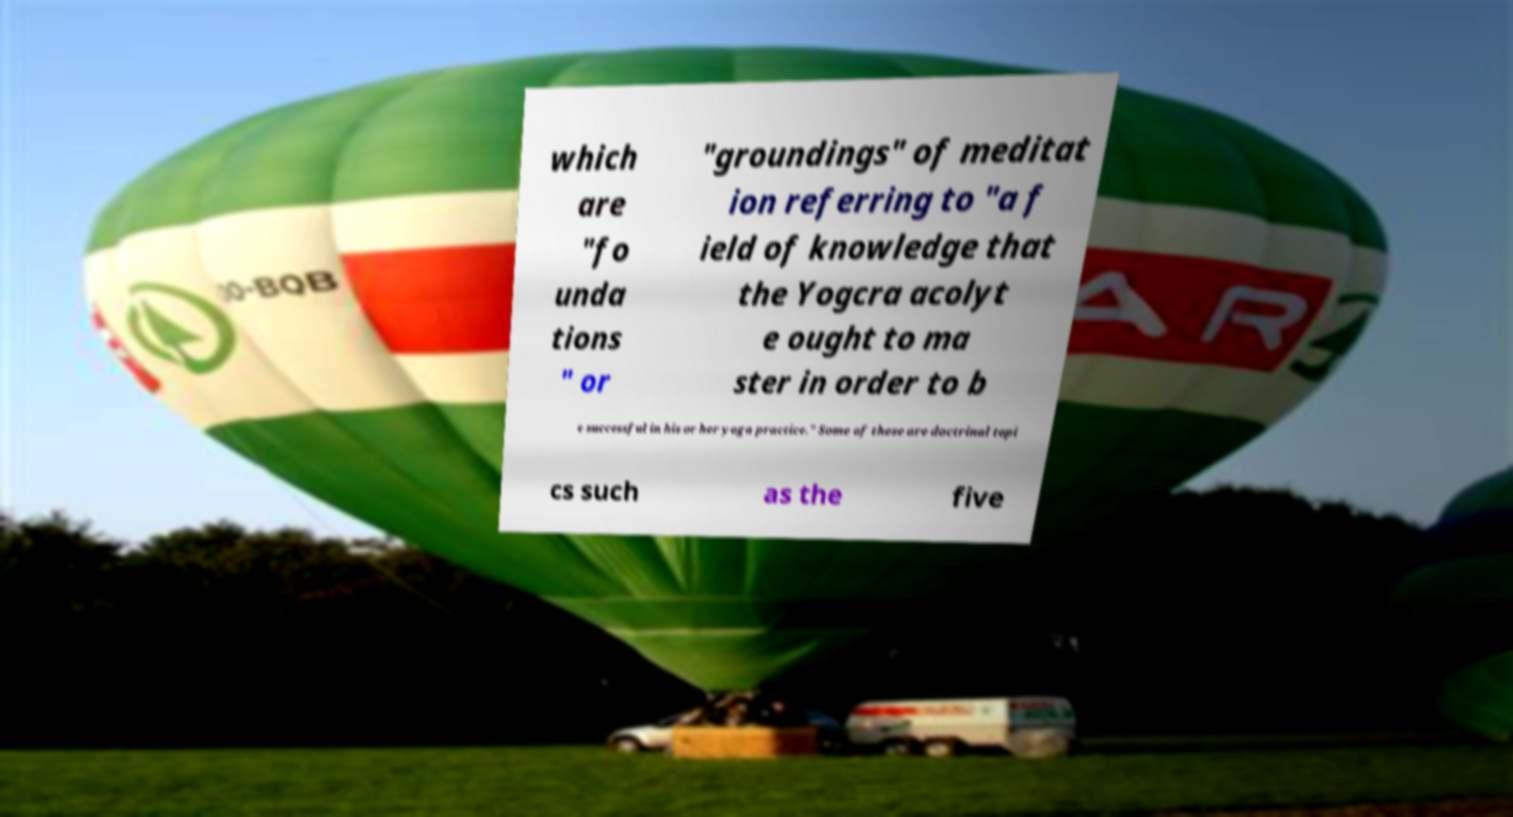Please read and relay the text visible in this image. What does it say? which are "fo unda tions " or "groundings" of meditat ion referring to "a f ield of knowledge that the Yogcra acolyt e ought to ma ster in order to b e successful in his or her yoga practice." Some of these are doctrinal topi cs such as the five 